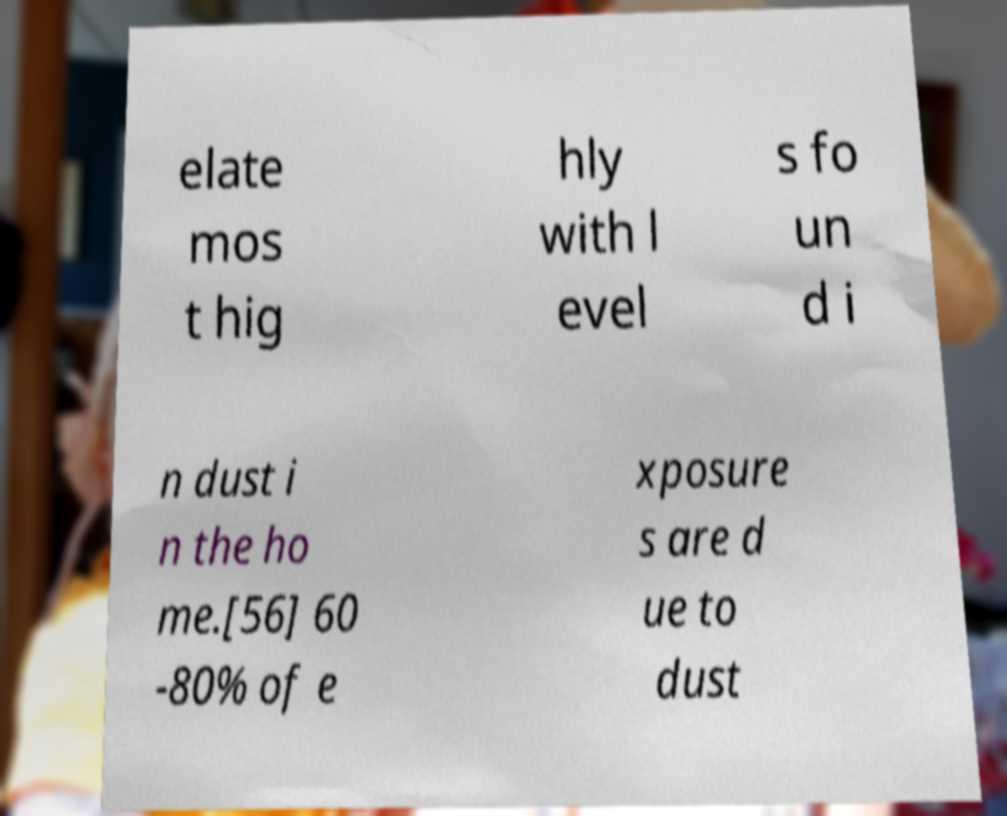For documentation purposes, I need the text within this image transcribed. Could you provide that? elate mos t hig hly with l evel s fo un d i n dust i n the ho me.[56] 60 -80% of e xposure s are d ue to dust 